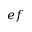Convert formula to latex. <formula><loc_0><loc_0><loc_500><loc_500>e f</formula> 